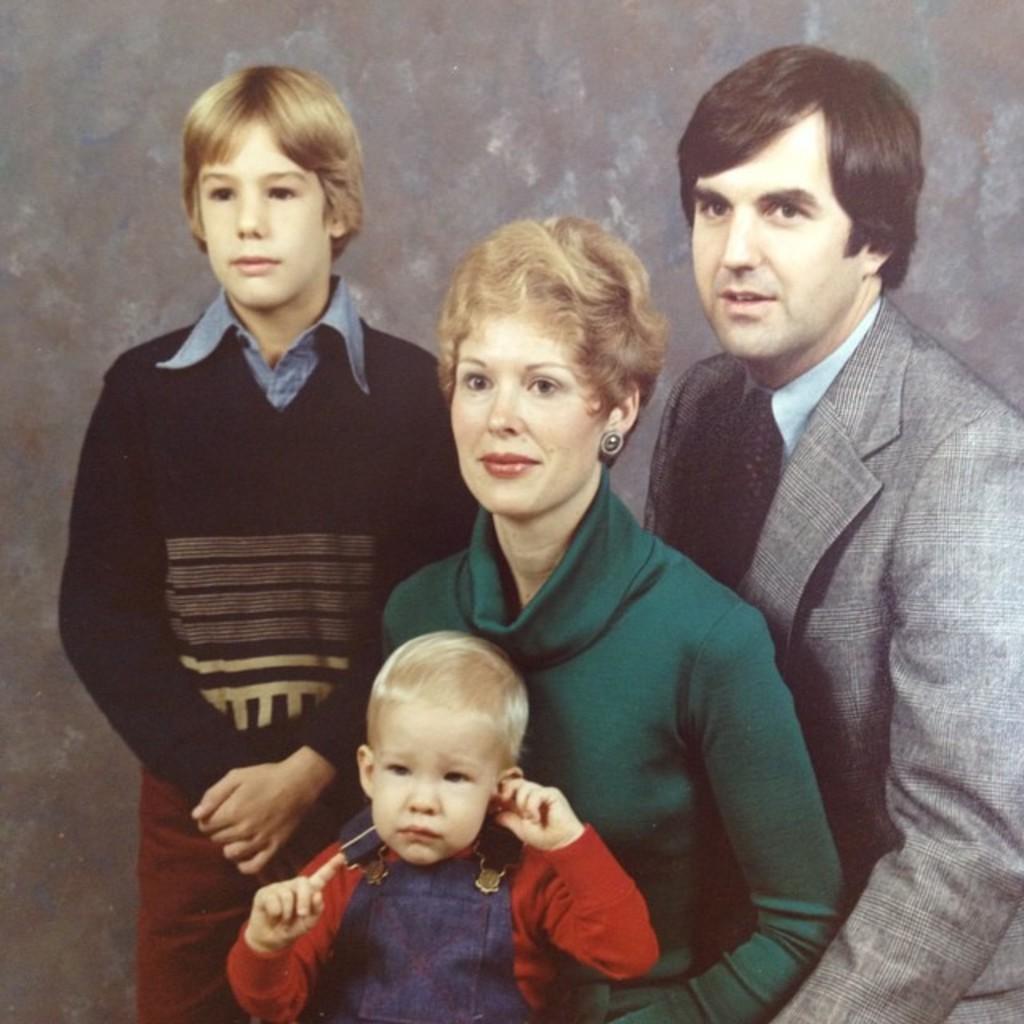Could you give a brief overview of what you see in this image? This picture describes about group of people, in the middle of the image we can see a woman, she wore a green color dress. 